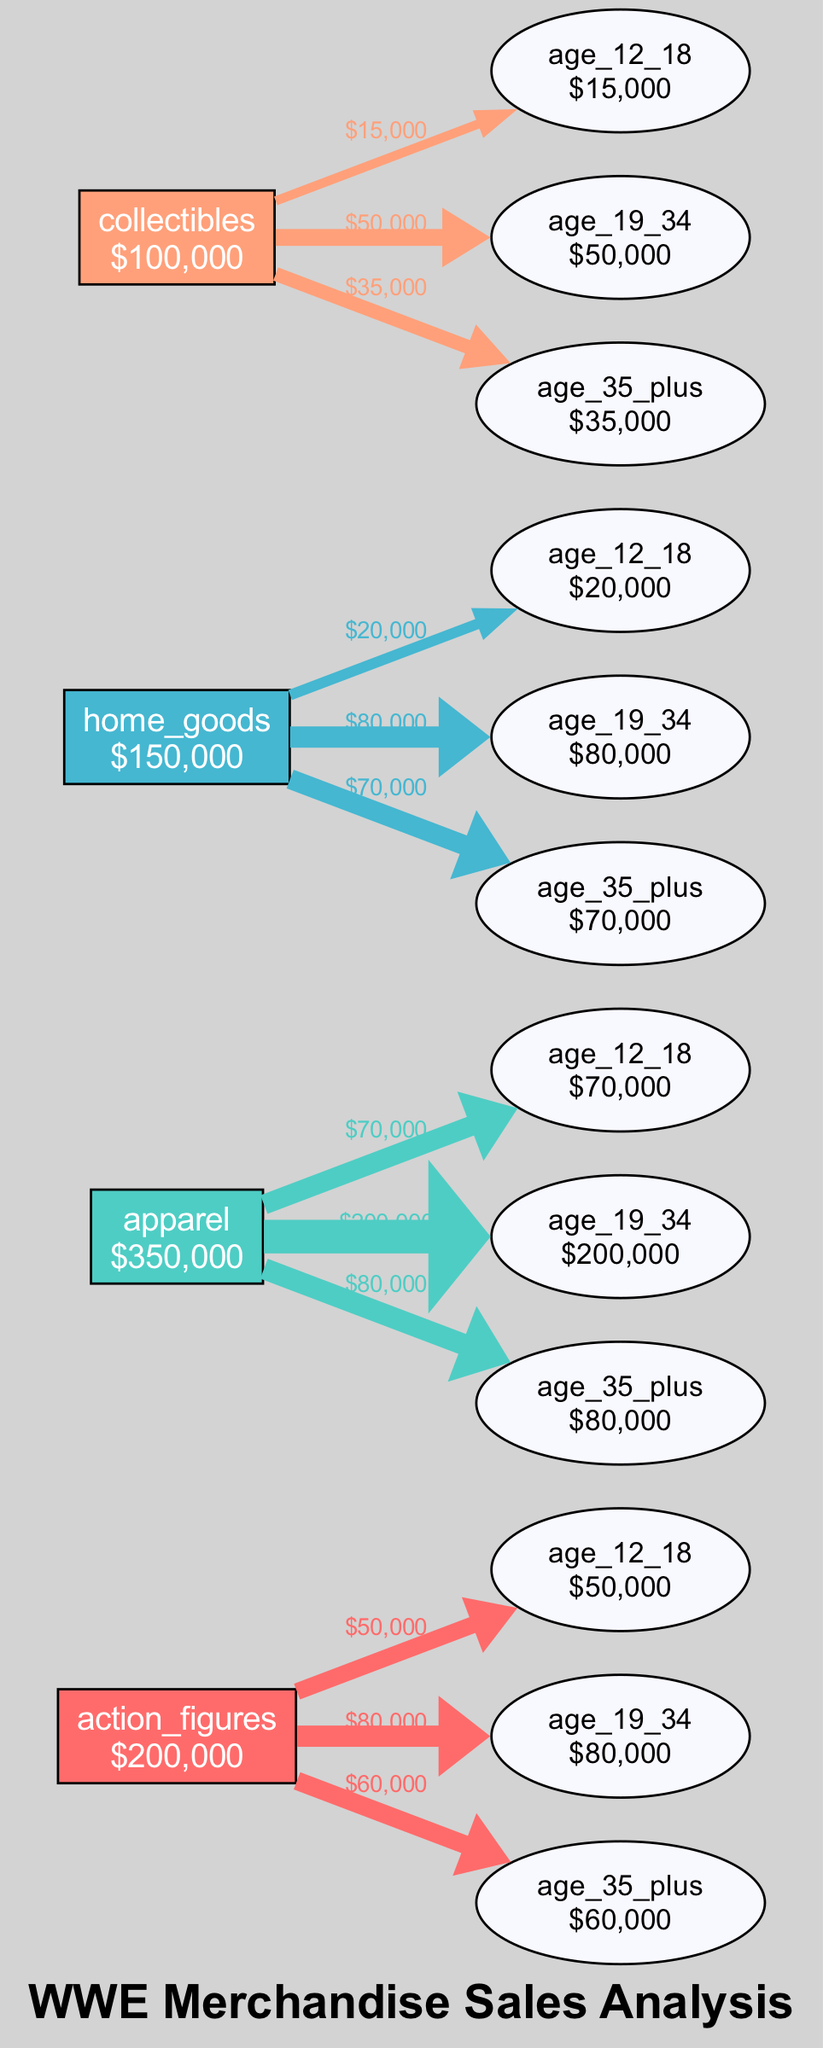What is the total sales for apparel? The apparel category's total sales can be found directly under its node, which states the total as 350,000 dollars.
Answer: 350,000 How many age groups are represented in the diagram? To determine the number of age groups, we count the distinct age demographic nodes connected to the product categories. There are three demographics: age 12-18, age 19-34, and age 35 plus.
Answer: 3 What percentage of total sales comes from action figures for age 19-34? The total sales for action figures is 200,000 dollars. The sales for age 19-34 demographic in this category is 80,000 dollars. To find the percentage, calculate (80,000/200,000)*100, which equals 40%.
Answer: 40% Which product category has the highest sales? By examining the total sales figures for each product category directly, we see that apparel has the highest total sales of 350,000 dollars, surpassing others.
Answer: apparel How much do age 12-18 customers contribute to the home goods category? The home goods category shows that age 12-18 customers contribute 20,000 dollars in sales, as indicated by the connecting edge between the demographic node and the home goods category.
Answer: 20,000 What is the total sales for the collectibles category compared to action figures? The total sales for collectibles is 100,000 dollars, while for action figures, it is 200,000 dollars. To find the comparison, note that collectibles have half the sales of action figures, so 100,000 is half of 200,000.
Answer: 100,000 Which demographic contributes the most sales to the apparel category? The demographic node for age 19-34 shows 200,000 dollars, indicating it contributes the most to apparel sales when compared to the others (age 12-18 and age 35 plus).
Answer: age 19-34 What is the total sales for all product categories combined? To find the total, we sum the sales from all categories: 200,000 (action figures) + 350,000 (apparel) + 150,000 (home goods) + 100,000 (collectibles), which results in 800,000 dollars.
Answer: 800,000 